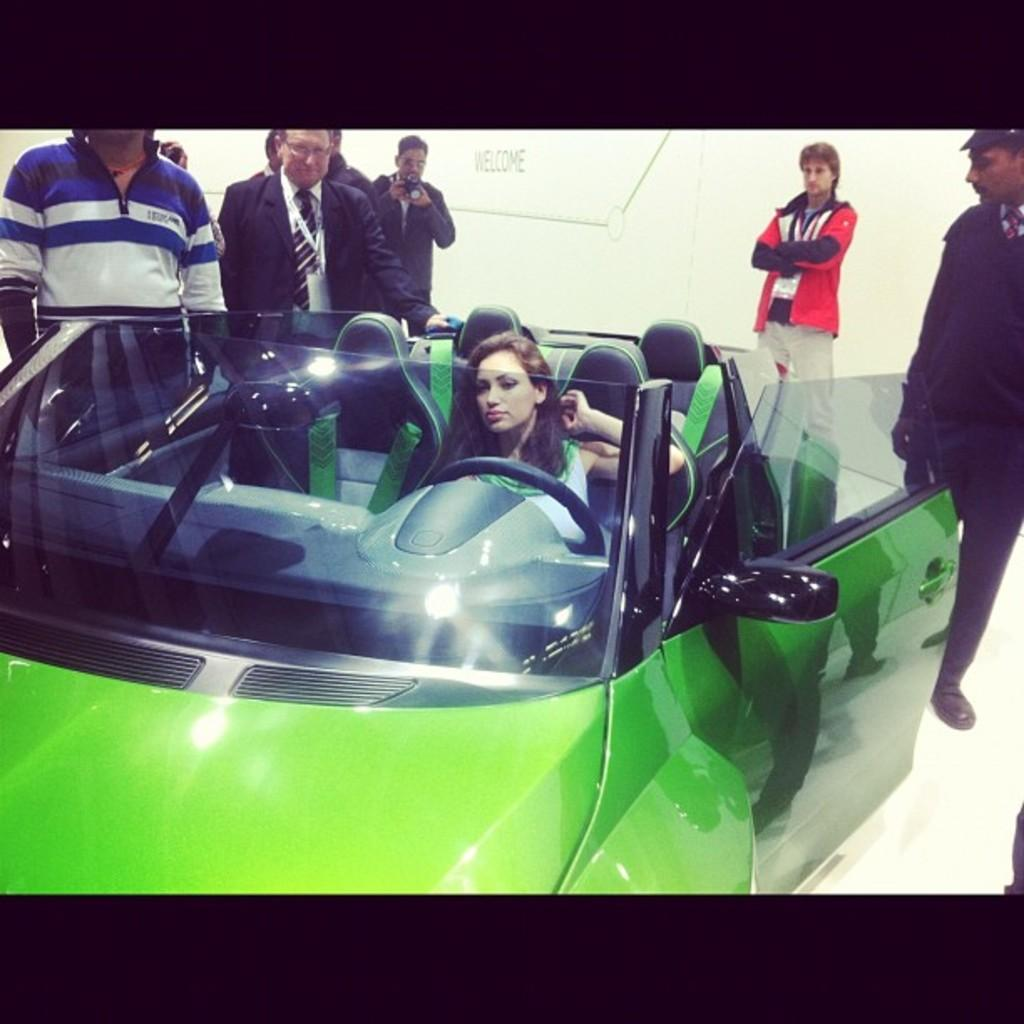What is the primary activity of the people in the image? There are people standing in the image, but their specific activity is not clear. Can you describe the woman's position in the image? There is a woman sitting in a car in the image. What type of society is depicted in the image? There is no specific society depicted in the image; it simply shows people standing and a woman sitting in a car. Can you tell me how many volleyballs are visible in the image? There are no volleyballs present in the image. Is the woman holding a rifle in the image? There is no rifle present in the image. 